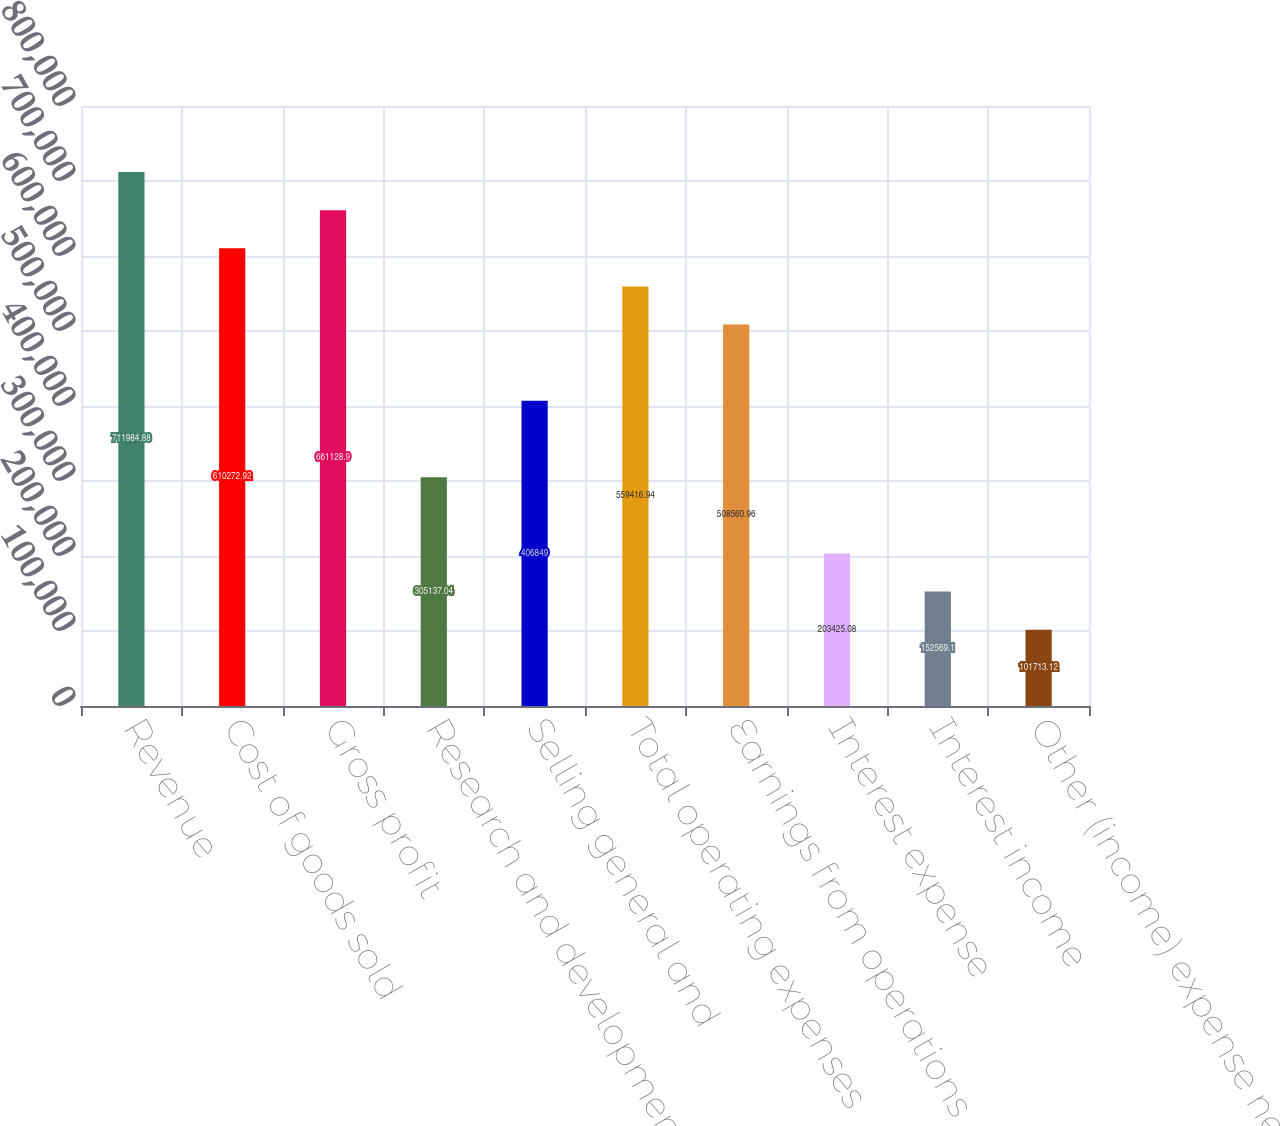<chart> <loc_0><loc_0><loc_500><loc_500><bar_chart><fcel>Revenue<fcel>Cost of goods sold<fcel>Gross profit<fcel>Research and development<fcel>Selling general and<fcel>Total operating expenses<fcel>Earnings from operations<fcel>Interest expense<fcel>Interest income<fcel>Other (income) expense net<nl><fcel>711985<fcel>610273<fcel>661129<fcel>305137<fcel>406849<fcel>559417<fcel>508561<fcel>203425<fcel>152569<fcel>101713<nl></chart> 